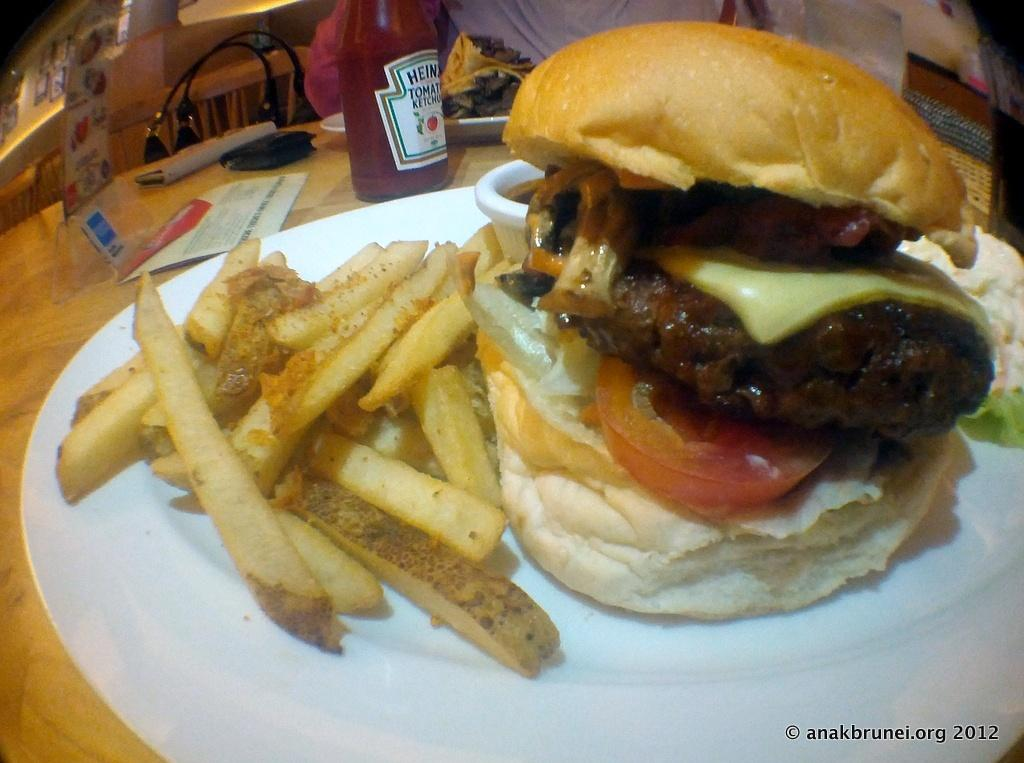What is on the plate that is visible in the image? The plate contains french fries and a burger. What type of food is not present on the plate? There is no pizza or salad present on the plate. What is located on the table in the image? There is a bottle on the table. What type of advice can be seen written on the burger in the image? There is no advice written on the burger in the image; it is a food item and not a source of advice. 